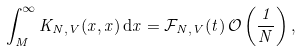Convert formula to latex. <formula><loc_0><loc_0><loc_500><loc_500>\int _ { M } ^ { \infty } K _ { N , V } ( x , x ) \, { \mathrm d } x = \mathcal { F } _ { N , V } ( t ) \, \mathcal { O } \left ( \frac { 1 } { N } \right ) ,</formula> 